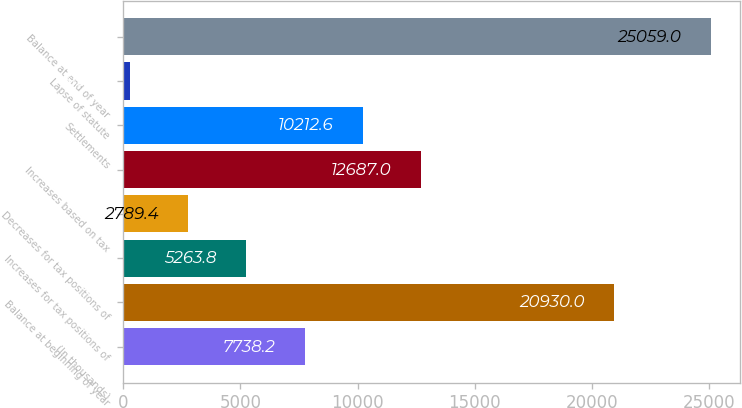Convert chart to OTSL. <chart><loc_0><loc_0><loc_500><loc_500><bar_chart><fcel>(In thousands)<fcel>Balance at beginning of year<fcel>Increases for tax positions of<fcel>Decreases for tax positions of<fcel>Increases based on tax<fcel>Settlements<fcel>Lapse of statute<fcel>Balance at end of year<nl><fcel>7738.2<fcel>20930<fcel>5263.8<fcel>2789.4<fcel>12687<fcel>10212.6<fcel>315<fcel>25059<nl></chart> 